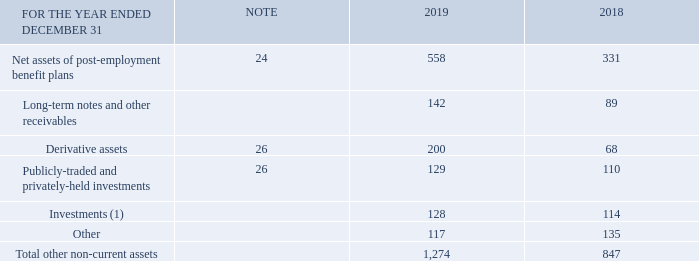Note 18 Other non-current assets
(1) These amounts have been pledged as security related to obligations for certain employee benefits and are not available for general use.
What have the amounts for other non-current assets investments been pledged as? Security related to obligations for certain employee benefits and are not available for general use. What is the amount of Investments in 2019? 128. What is the amount of Derivative assets in 2018? 68. What is the percentage change in net assets of post-employment benefit plans in 2019?
Answer scale should be: percent. (558-331)/331
Answer: 68.58. What is the change in net assets of post-employment benefit plans in 2019? 558-331
Answer: 227. What is the change in the total other non-current assets in 2019?  1,274-847
Answer: 427. 